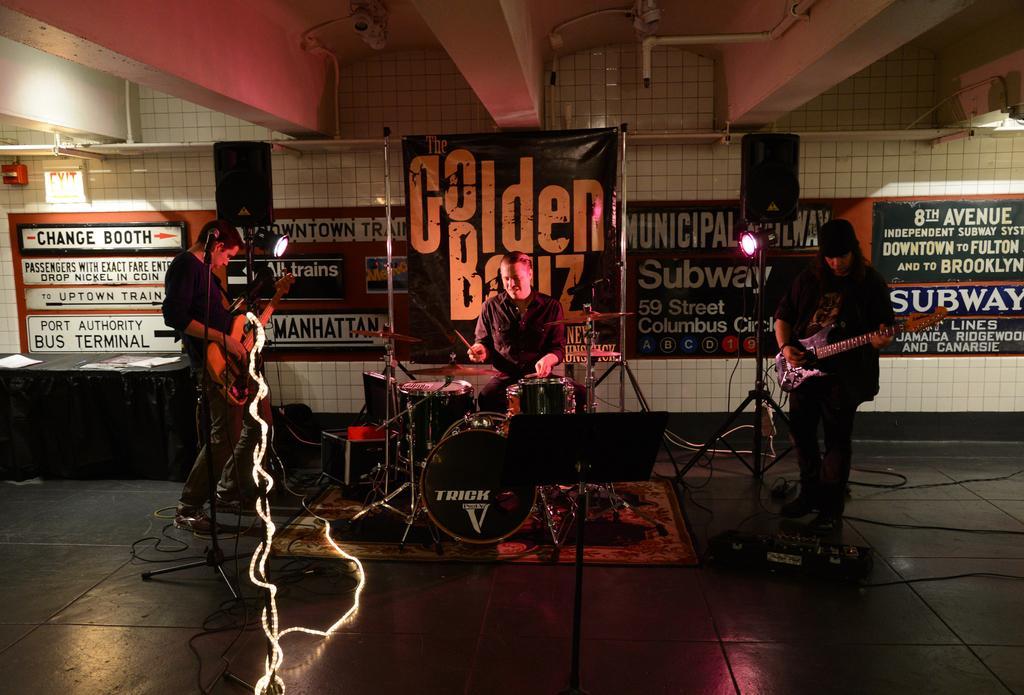Describe this image in one or two sentences. In this picture we can see two persons are playing guitar. This is floor. Here we can see a man who is playing drums. On the background there is a wall and there is a banner. And this is light. 